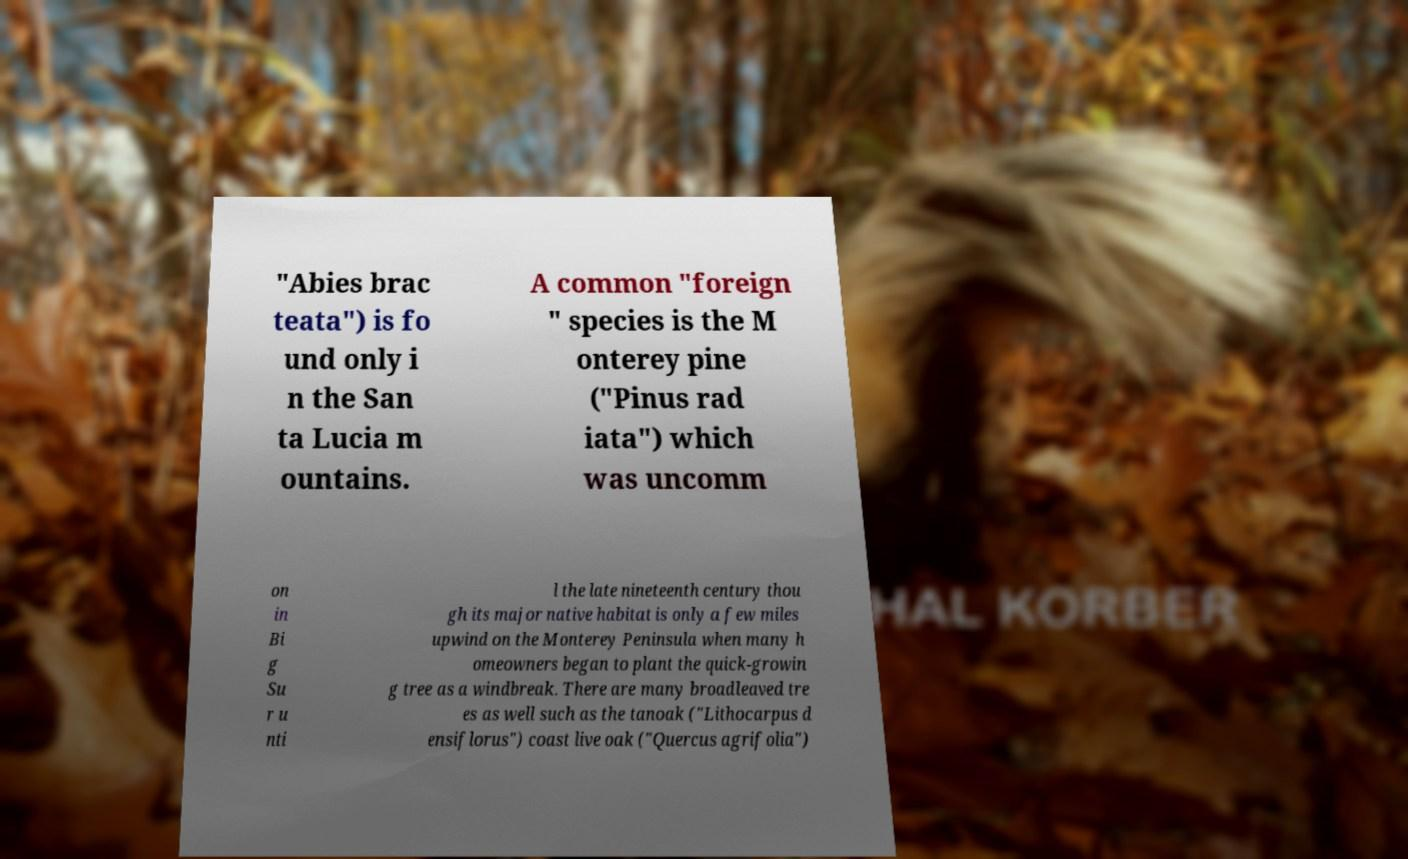There's text embedded in this image that I need extracted. Can you transcribe it verbatim? "Abies brac teata") is fo und only i n the San ta Lucia m ountains. A common "foreign " species is the M onterey pine ("Pinus rad iata") which was uncomm on in Bi g Su r u nti l the late nineteenth century thou gh its major native habitat is only a few miles upwind on the Monterey Peninsula when many h omeowners began to plant the quick-growin g tree as a windbreak. There are many broadleaved tre es as well such as the tanoak ("Lithocarpus d ensiflorus") coast live oak ("Quercus agrifolia") 